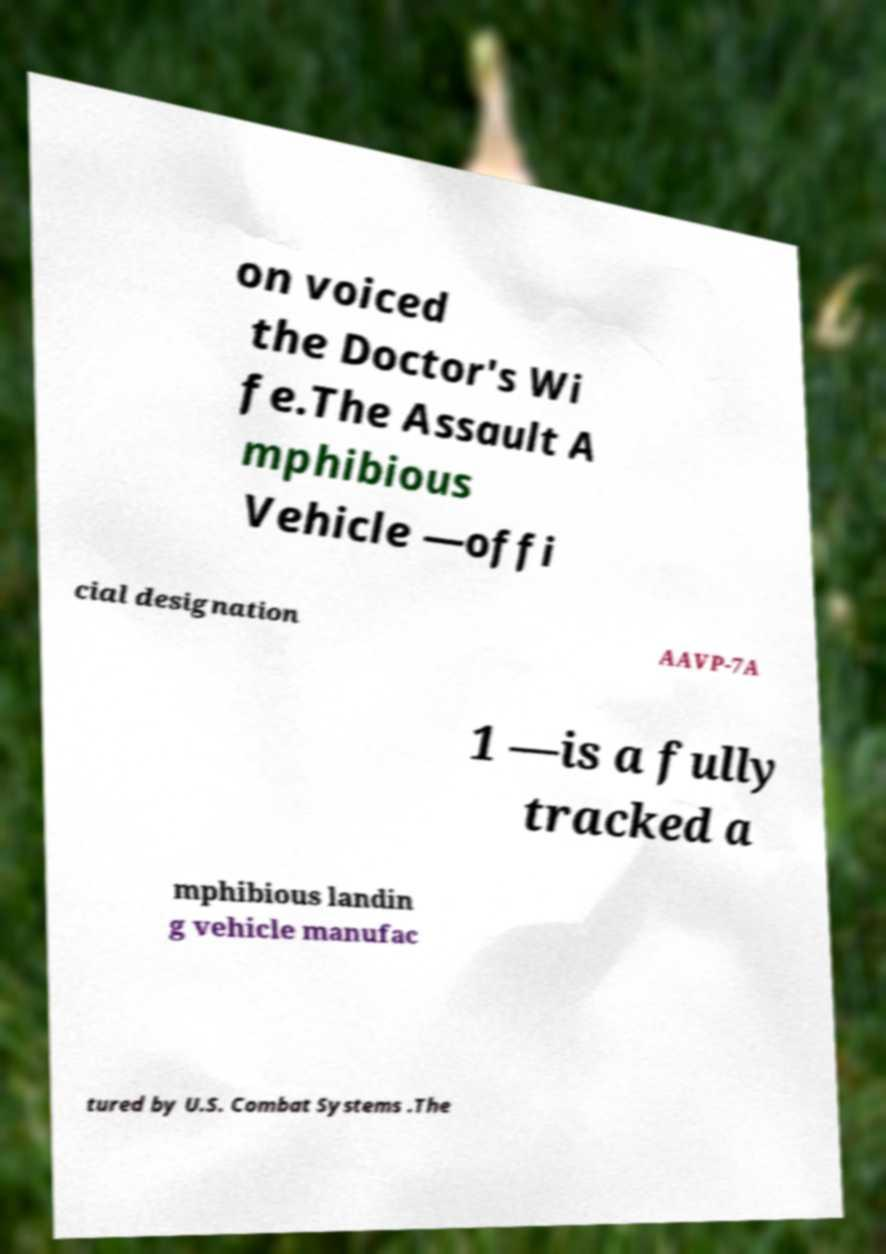Please read and relay the text visible in this image. What does it say? on voiced the Doctor's Wi fe.The Assault A mphibious Vehicle —offi cial designation AAVP-7A 1 —is a fully tracked a mphibious landin g vehicle manufac tured by U.S. Combat Systems .The 